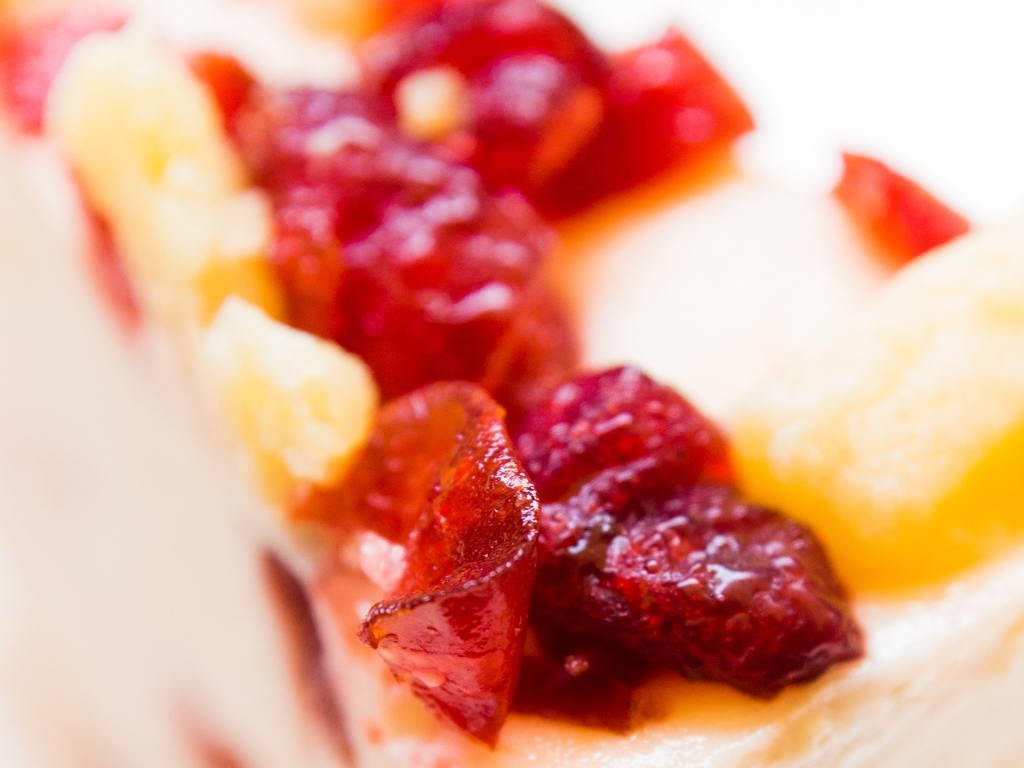How are the details and textures on the objects' surfaces? The objects' surfaces in the image exhibit a high degree of clarity, showcasing rich textures and details. The luscious reds and warm yellows of the chopped fruits are vivid and well-defined, giving a tangible sense of their juicy, succulent nature. 